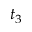Convert formula to latex. <formula><loc_0><loc_0><loc_500><loc_500>t _ { 3 }</formula> 